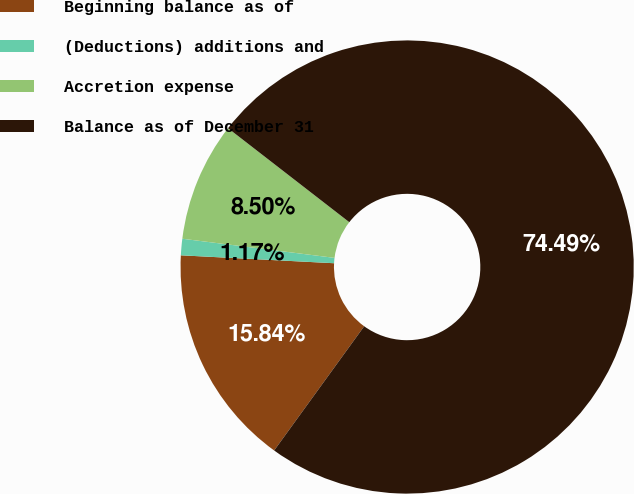Convert chart to OTSL. <chart><loc_0><loc_0><loc_500><loc_500><pie_chart><fcel>Beginning balance as of<fcel>(Deductions) additions and<fcel>Accretion expense<fcel>Balance as of December 31<nl><fcel>15.84%<fcel>1.17%<fcel>8.5%<fcel>74.49%<nl></chart> 